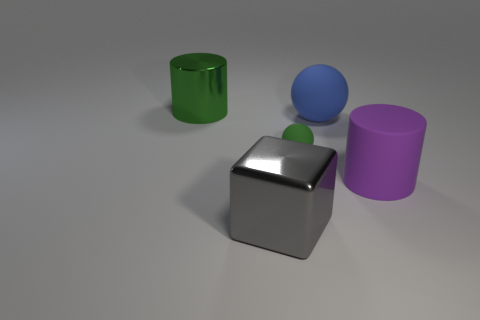Add 5 big blue balls. How many objects exist? 10 Subtract all spheres. How many objects are left? 3 Add 1 purple rubber cylinders. How many purple rubber cylinders exist? 2 Subtract 0 cyan cylinders. How many objects are left? 5 Subtract all small brown matte cubes. Subtract all large gray objects. How many objects are left? 4 Add 1 large blocks. How many large blocks are left? 2 